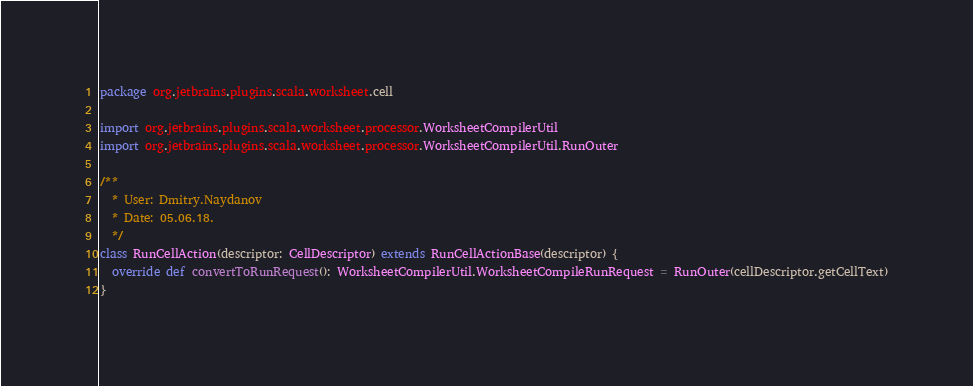<code> <loc_0><loc_0><loc_500><loc_500><_Scala_>package org.jetbrains.plugins.scala.worksheet.cell

import org.jetbrains.plugins.scala.worksheet.processor.WorksheetCompilerUtil
import org.jetbrains.plugins.scala.worksheet.processor.WorksheetCompilerUtil.RunOuter

/**
  * User: Dmitry.Naydanov
  * Date: 05.06.18.
  */
class RunCellAction(descriptor: CellDescriptor) extends RunCellActionBase(descriptor) {
  override def convertToRunRequest(): WorksheetCompilerUtil.WorksheetCompileRunRequest = RunOuter(cellDescriptor.getCellText)
}
</code> 